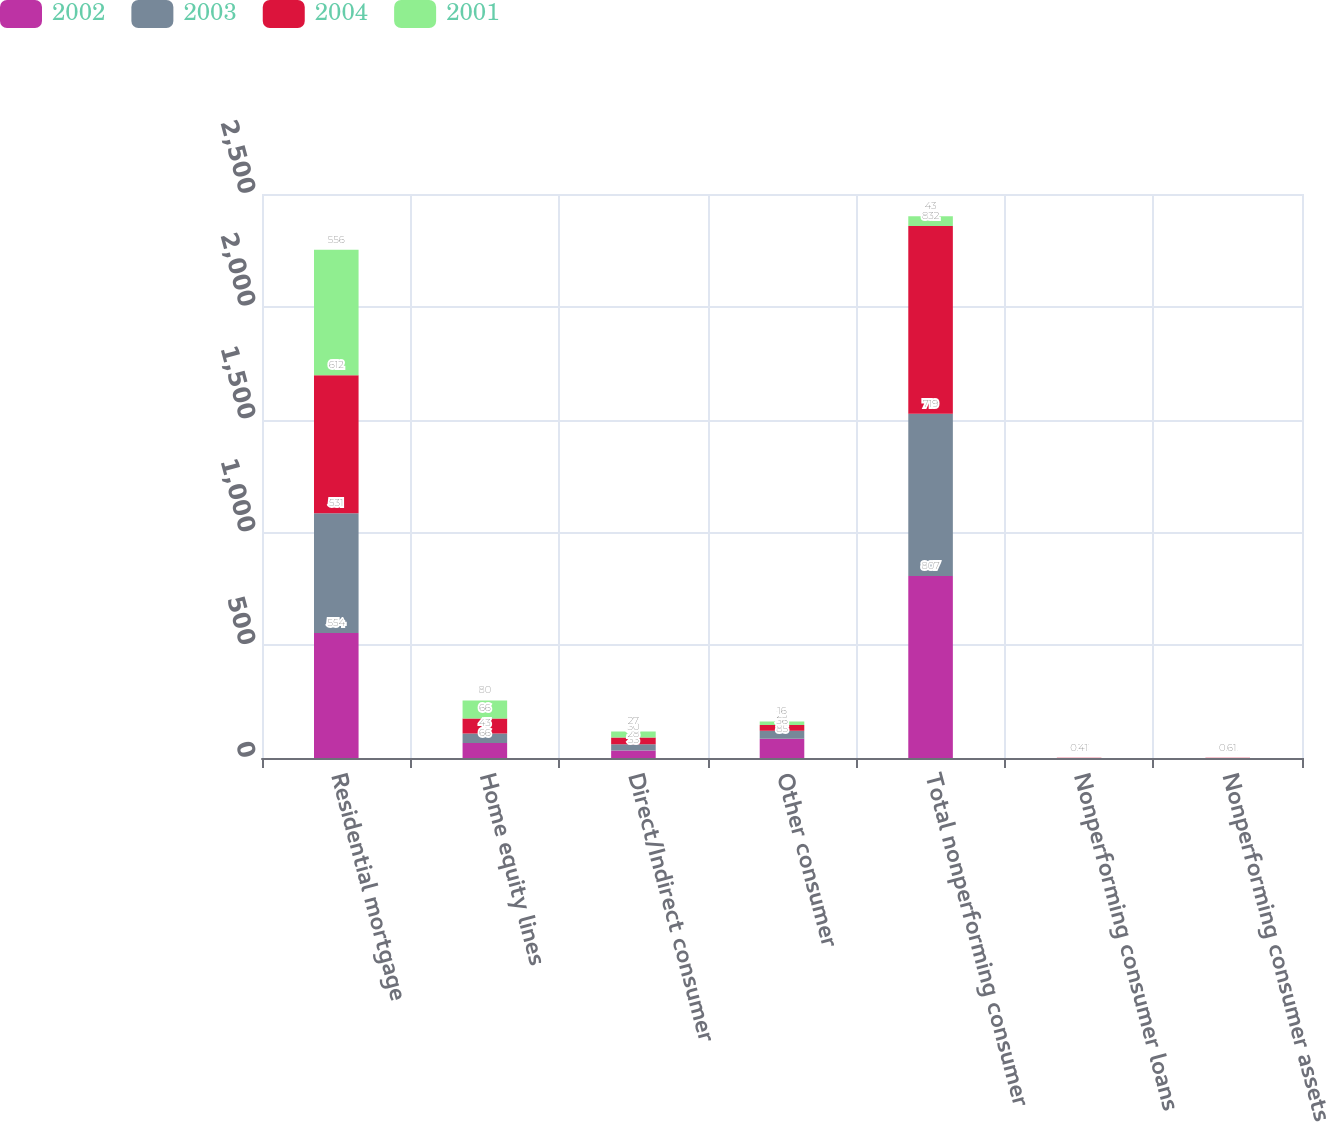Convert chart. <chart><loc_0><loc_0><loc_500><loc_500><stacked_bar_chart><ecel><fcel>Residential mortgage<fcel>Home equity lines<fcel>Direct/Indirect consumer<fcel>Other consumer<fcel>Total nonperforming consumer<fcel>Nonperforming consumer loans<fcel>Nonperforming consumer assets<nl><fcel>2002<fcel>554<fcel>66<fcel>33<fcel>85<fcel>807<fcel>0.23<fcel>0.25<nl><fcel>2003<fcel>531<fcel>43<fcel>28<fcel>36<fcel>719<fcel>0.27<fcel>0.3<nl><fcel>2004<fcel>612<fcel>66<fcel>30<fcel>25<fcel>832<fcel>0.37<fcel>0.42<nl><fcel>2001<fcel>556<fcel>80<fcel>27<fcel>16<fcel>43<fcel>0.41<fcel>0.61<nl></chart> 